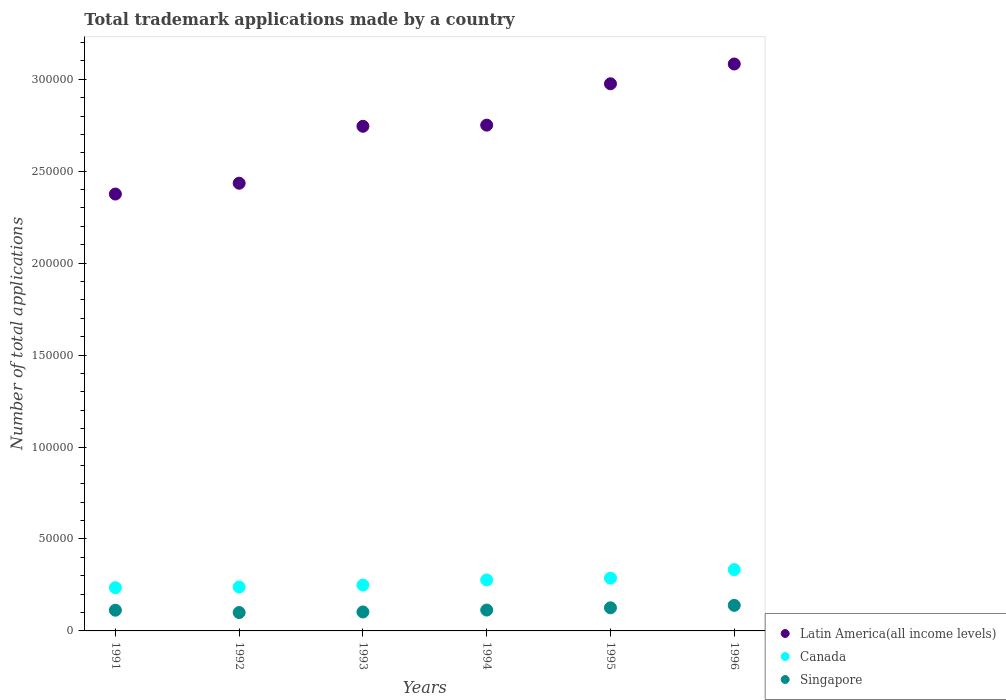What is the number of applications made by in Canada in 1994?
Make the answer very short. 2.77e+04. Across all years, what is the maximum number of applications made by in Singapore?
Offer a terse response. 1.39e+04. Across all years, what is the minimum number of applications made by in Singapore?
Make the answer very short. 9999. In which year was the number of applications made by in Singapore maximum?
Offer a terse response. 1996. What is the total number of applications made by in Singapore in the graph?
Make the answer very short. 6.94e+04. What is the difference between the number of applications made by in Singapore in 1993 and that in 1996?
Offer a terse response. -3588. What is the difference between the number of applications made by in Latin America(all income levels) in 1993 and the number of applications made by in Canada in 1996?
Give a very brief answer. 2.41e+05. What is the average number of applications made by in Canada per year?
Give a very brief answer. 2.70e+04. In the year 1993, what is the difference between the number of applications made by in Latin America(all income levels) and number of applications made by in Singapore?
Your response must be concise. 2.64e+05. What is the ratio of the number of applications made by in Singapore in 1991 to that in 1992?
Ensure brevity in your answer.  1.13. What is the difference between the highest and the second highest number of applications made by in Canada?
Ensure brevity in your answer.  4637. What is the difference between the highest and the lowest number of applications made by in Canada?
Offer a terse response. 9828. In how many years, is the number of applications made by in Canada greater than the average number of applications made by in Canada taken over all years?
Make the answer very short. 3. Is the sum of the number of applications made by in Canada in 1991 and 1993 greater than the maximum number of applications made by in Latin America(all income levels) across all years?
Your answer should be compact. No. Is the number of applications made by in Singapore strictly less than the number of applications made by in Canada over the years?
Your answer should be very brief. Yes. How many dotlines are there?
Ensure brevity in your answer.  3. Does the graph contain any zero values?
Provide a short and direct response. No. Where does the legend appear in the graph?
Your response must be concise. Bottom right. What is the title of the graph?
Your response must be concise. Total trademark applications made by a country. What is the label or title of the Y-axis?
Keep it short and to the point. Number of total applications. What is the Number of total applications of Latin America(all income levels) in 1991?
Your response must be concise. 2.38e+05. What is the Number of total applications of Canada in 1991?
Keep it short and to the point. 2.35e+04. What is the Number of total applications in Singapore in 1991?
Provide a succinct answer. 1.13e+04. What is the Number of total applications in Latin America(all income levels) in 1992?
Keep it short and to the point. 2.43e+05. What is the Number of total applications in Canada in 1992?
Keep it short and to the point. 2.39e+04. What is the Number of total applications of Singapore in 1992?
Your response must be concise. 9999. What is the Number of total applications in Latin America(all income levels) in 1993?
Offer a terse response. 2.74e+05. What is the Number of total applications in Canada in 1993?
Give a very brief answer. 2.49e+04. What is the Number of total applications in Singapore in 1993?
Offer a very short reply. 1.03e+04. What is the Number of total applications in Latin America(all income levels) in 1994?
Your response must be concise. 2.75e+05. What is the Number of total applications in Canada in 1994?
Give a very brief answer. 2.77e+04. What is the Number of total applications of Singapore in 1994?
Provide a short and direct response. 1.13e+04. What is the Number of total applications of Latin America(all income levels) in 1995?
Your response must be concise. 2.98e+05. What is the Number of total applications of Canada in 1995?
Your answer should be very brief. 2.87e+04. What is the Number of total applications in Singapore in 1995?
Provide a short and direct response. 1.26e+04. What is the Number of total applications of Latin America(all income levels) in 1996?
Make the answer very short. 3.08e+05. What is the Number of total applications of Canada in 1996?
Provide a short and direct response. 3.33e+04. What is the Number of total applications of Singapore in 1996?
Your response must be concise. 1.39e+04. Across all years, what is the maximum Number of total applications in Latin America(all income levels)?
Your answer should be very brief. 3.08e+05. Across all years, what is the maximum Number of total applications of Canada?
Keep it short and to the point. 3.33e+04. Across all years, what is the maximum Number of total applications in Singapore?
Offer a very short reply. 1.39e+04. Across all years, what is the minimum Number of total applications in Latin America(all income levels)?
Your answer should be very brief. 2.38e+05. Across all years, what is the minimum Number of total applications in Canada?
Provide a succinct answer. 2.35e+04. Across all years, what is the minimum Number of total applications of Singapore?
Offer a very short reply. 9999. What is the total Number of total applications of Latin America(all income levels) in the graph?
Give a very brief answer. 1.64e+06. What is the total Number of total applications in Canada in the graph?
Make the answer very short. 1.62e+05. What is the total Number of total applications in Singapore in the graph?
Your response must be concise. 6.94e+04. What is the difference between the Number of total applications in Latin America(all income levels) in 1991 and that in 1992?
Ensure brevity in your answer.  -5886. What is the difference between the Number of total applications of Canada in 1991 and that in 1992?
Make the answer very short. -362. What is the difference between the Number of total applications in Singapore in 1991 and that in 1992?
Offer a very short reply. 1267. What is the difference between the Number of total applications in Latin America(all income levels) in 1991 and that in 1993?
Your answer should be compact. -3.69e+04. What is the difference between the Number of total applications in Canada in 1991 and that in 1993?
Your answer should be compact. -1424. What is the difference between the Number of total applications in Singapore in 1991 and that in 1993?
Your answer should be compact. 955. What is the difference between the Number of total applications of Latin America(all income levels) in 1991 and that in 1994?
Your answer should be compact. -3.75e+04. What is the difference between the Number of total applications of Canada in 1991 and that in 1994?
Provide a succinct answer. -4217. What is the difference between the Number of total applications in Singapore in 1991 and that in 1994?
Provide a short and direct response. -83. What is the difference between the Number of total applications in Latin America(all income levels) in 1991 and that in 1995?
Ensure brevity in your answer.  -6.00e+04. What is the difference between the Number of total applications in Canada in 1991 and that in 1995?
Keep it short and to the point. -5191. What is the difference between the Number of total applications in Singapore in 1991 and that in 1995?
Your answer should be very brief. -1311. What is the difference between the Number of total applications of Latin America(all income levels) in 1991 and that in 1996?
Your answer should be very brief. -7.07e+04. What is the difference between the Number of total applications of Canada in 1991 and that in 1996?
Offer a very short reply. -9828. What is the difference between the Number of total applications of Singapore in 1991 and that in 1996?
Your response must be concise. -2633. What is the difference between the Number of total applications of Latin America(all income levels) in 1992 and that in 1993?
Your answer should be very brief. -3.10e+04. What is the difference between the Number of total applications in Canada in 1992 and that in 1993?
Make the answer very short. -1062. What is the difference between the Number of total applications of Singapore in 1992 and that in 1993?
Offer a terse response. -312. What is the difference between the Number of total applications in Latin America(all income levels) in 1992 and that in 1994?
Give a very brief answer. -3.16e+04. What is the difference between the Number of total applications in Canada in 1992 and that in 1994?
Your response must be concise. -3855. What is the difference between the Number of total applications in Singapore in 1992 and that in 1994?
Make the answer very short. -1350. What is the difference between the Number of total applications of Latin America(all income levels) in 1992 and that in 1995?
Your answer should be compact. -5.41e+04. What is the difference between the Number of total applications in Canada in 1992 and that in 1995?
Your response must be concise. -4829. What is the difference between the Number of total applications in Singapore in 1992 and that in 1995?
Offer a very short reply. -2578. What is the difference between the Number of total applications in Latin America(all income levels) in 1992 and that in 1996?
Ensure brevity in your answer.  -6.48e+04. What is the difference between the Number of total applications in Canada in 1992 and that in 1996?
Keep it short and to the point. -9466. What is the difference between the Number of total applications of Singapore in 1992 and that in 1996?
Ensure brevity in your answer.  -3900. What is the difference between the Number of total applications in Latin America(all income levels) in 1993 and that in 1994?
Offer a very short reply. -624. What is the difference between the Number of total applications in Canada in 1993 and that in 1994?
Provide a short and direct response. -2793. What is the difference between the Number of total applications in Singapore in 1993 and that in 1994?
Your answer should be compact. -1038. What is the difference between the Number of total applications of Latin America(all income levels) in 1993 and that in 1995?
Provide a succinct answer. -2.31e+04. What is the difference between the Number of total applications of Canada in 1993 and that in 1995?
Provide a short and direct response. -3767. What is the difference between the Number of total applications of Singapore in 1993 and that in 1995?
Provide a succinct answer. -2266. What is the difference between the Number of total applications in Latin America(all income levels) in 1993 and that in 1996?
Keep it short and to the point. -3.39e+04. What is the difference between the Number of total applications in Canada in 1993 and that in 1996?
Make the answer very short. -8404. What is the difference between the Number of total applications of Singapore in 1993 and that in 1996?
Your answer should be very brief. -3588. What is the difference between the Number of total applications of Latin America(all income levels) in 1994 and that in 1995?
Ensure brevity in your answer.  -2.25e+04. What is the difference between the Number of total applications of Canada in 1994 and that in 1995?
Keep it short and to the point. -974. What is the difference between the Number of total applications of Singapore in 1994 and that in 1995?
Your answer should be very brief. -1228. What is the difference between the Number of total applications in Latin America(all income levels) in 1994 and that in 1996?
Your response must be concise. -3.32e+04. What is the difference between the Number of total applications of Canada in 1994 and that in 1996?
Keep it short and to the point. -5611. What is the difference between the Number of total applications of Singapore in 1994 and that in 1996?
Give a very brief answer. -2550. What is the difference between the Number of total applications of Latin America(all income levels) in 1995 and that in 1996?
Provide a succinct answer. -1.07e+04. What is the difference between the Number of total applications in Canada in 1995 and that in 1996?
Your response must be concise. -4637. What is the difference between the Number of total applications in Singapore in 1995 and that in 1996?
Offer a terse response. -1322. What is the difference between the Number of total applications in Latin America(all income levels) in 1991 and the Number of total applications in Canada in 1992?
Your answer should be compact. 2.14e+05. What is the difference between the Number of total applications of Latin America(all income levels) in 1991 and the Number of total applications of Singapore in 1992?
Your response must be concise. 2.28e+05. What is the difference between the Number of total applications of Canada in 1991 and the Number of total applications of Singapore in 1992?
Keep it short and to the point. 1.35e+04. What is the difference between the Number of total applications in Latin America(all income levels) in 1991 and the Number of total applications in Canada in 1993?
Make the answer very short. 2.13e+05. What is the difference between the Number of total applications in Latin America(all income levels) in 1991 and the Number of total applications in Singapore in 1993?
Ensure brevity in your answer.  2.27e+05. What is the difference between the Number of total applications in Canada in 1991 and the Number of total applications in Singapore in 1993?
Your response must be concise. 1.32e+04. What is the difference between the Number of total applications in Latin America(all income levels) in 1991 and the Number of total applications in Canada in 1994?
Ensure brevity in your answer.  2.10e+05. What is the difference between the Number of total applications in Latin America(all income levels) in 1991 and the Number of total applications in Singapore in 1994?
Your answer should be compact. 2.26e+05. What is the difference between the Number of total applications in Canada in 1991 and the Number of total applications in Singapore in 1994?
Your answer should be compact. 1.22e+04. What is the difference between the Number of total applications in Latin America(all income levels) in 1991 and the Number of total applications in Canada in 1995?
Provide a succinct answer. 2.09e+05. What is the difference between the Number of total applications of Latin America(all income levels) in 1991 and the Number of total applications of Singapore in 1995?
Offer a very short reply. 2.25e+05. What is the difference between the Number of total applications in Canada in 1991 and the Number of total applications in Singapore in 1995?
Offer a terse response. 1.09e+04. What is the difference between the Number of total applications in Latin America(all income levels) in 1991 and the Number of total applications in Canada in 1996?
Make the answer very short. 2.04e+05. What is the difference between the Number of total applications of Latin America(all income levels) in 1991 and the Number of total applications of Singapore in 1996?
Make the answer very short. 2.24e+05. What is the difference between the Number of total applications in Canada in 1991 and the Number of total applications in Singapore in 1996?
Provide a short and direct response. 9614. What is the difference between the Number of total applications of Latin America(all income levels) in 1992 and the Number of total applications of Canada in 1993?
Your answer should be compact. 2.19e+05. What is the difference between the Number of total applications in Latin America(all income levels) in 1992 and the Number of total applications in Singapore in 1993?
Offer a terse response. 2.33e+05. What is the difference between the Number of total applications of Canada in 1992 and the Number of total applications of Singapore in 1993?
Your response must be concise. 1.36e+04. What is the difference between the Number of total applications of Latin America(all income levels) in 1992 and the Number of total applications of Canada in 1994?
Make the answer very short. 2.16e+05. What is the difference between the Number of total applications of Latin America(all income levels) in 1992 and the Number of total applications of Singapore in 1994?
Offer a very short reply. 2.32e+05. What is the difference between the Number of total applications in Canada in 1992 and the Number of total applications in Singapore in 1994?
Give a very brief answer. 1.25e+04. What is the difference between the Number of total applications of Latin America(all income levels) in 1992 and the Number of total applications of Canada in 1995?
Provide a succinct answer. 2.15e+05. What is the difference between the Number of total applications in Latin America(all income levels) in 1992 and the Number of total applications in Singapore in 1995?
Your answer should be very brief. 2.31e+05. What is the difference between the Number of total applications of Canada in 1992 and the Number of total applications of Singapore in 1995?
Provide a succinct answer. 1.13e+04. What is the difference between the Number of total applications of Latin America(all income levels) in 1992 and the Number of total applications of Canada in 1996?
Keep it short and to the point. 2.10e+05. What is the difference between the Number of total applications in Latin America(all income levels) in 1992 and the Number of total applications in Singapore in 1996?
Ensure brevity in your answer.  2.30e+05. What is the difference between the Number of total applications in Canada in 1992 and the Number of total applications in Singapore in 1996?
Make the answer very short. 9976. What is the difference between the Number of total applications in Latin America(all income levels) in 1993 and the Number of total applications in Canada in 1994?
Offer a terse response. 2.47e+05. What is the difference between the Number of total applications of Latin America(all income levels) in 1993 and the Number of total applications of Singapore in 1994?
Keep it short and to the point. 2.63e+05. What is the difference between the Number of total applications of Canada in 1993 and the Number of total applications of Singapore in 1994?
Your answer should be compact. 1.36e+04. What is the difference between the Number of total applications in Latin America(all income levels) in 1993 and the Number of total applications in Canada in 1995?
Ensure brevity in your answer.  2.46e+05. What is the difference between the Number of total applications of Latin America(all income levels) in 1993 and the Number of total applications of Singapore in 1995?
Make the answer very short. 2.62e+05. What is the difference between the Number of total applications of Canada in 1993 and the Number of total applications of Singapore in 1995?
Give a very brief answer. 1.24e+04. What is the difference between the Number of total applications in Latin America(all income levels) in 1993 and the Number of total applications in Canada in 1996?
Keep it short and to the point. 2.41e+05. What is the difference between the Number of total applications in Latin America(all income levels) in 1993 and the Number of total applications in Singapore in 1996?
Offer a very short reply. 2.61e+05. What is the difference between the Number of total applications in Canada in 1993 and the Number of total applications in Singapore in 1996?
Make the answer very short. 1.10e+04. What is the difference between the Number of total applications in Latin America(all income levels) in 1994 and the Number of total applications in Canada in 1995?
Offer a terse response. 2.46e+05. What is the difference between the Number of total applications of Latin America(all income levels) in 1994 and the Number of total applications of Singapore in 1995?
Provide a short and direct response. 2.62e+05. What is the difference between the Number of total applications of Canada in 1994 and the Number of total applications of Singapore in 1995?
Offer a very short reply. 1.52e+04. What is the difference between the Number of total applications of Latin America(all income levels) in 1994 and the Number of total applications of Canada in 1996?
Your answer should be very brief. 2.42e+05. What is the difference between the Number of total applications in Latin America(all income levels) in 1994 and the Number of total applications in Singapore in 1996?
Ensure brevity in your answer.  2.61e+05. What is the difference between the Number of total applications in Canada in 1994 and the Number of total applications in Singapore in 1996?
Ensure brevity in your answer.  1.38e+04. What is the difference between the Number of total applications in Latin America(all income levels) in 1995 and the Number of total applications in Canada in 1996?
Your answer should be compact. 2.64e+05. What is the difference between the Number of total applications in Latin America(all income levels) in 1995 and the Number of total applications in Singapore in 1996?
Provide a short and direct response. 2.84e+05. What is the difference between the Number of total applications in Canada in 1995 and the Number of total applications in Singapore in 1996?
Offer a terse response. 1.48e+04. What is the average Number of total applications in Latin America(all income levels) per year?
Provide a short and direct response. 2.73e+05. What is the average Number of total applications in Canada per year?
Make the answer very short. 2.70e+04. What is the average Number of total applications in Singapore per year?
Your response must be concise. 1.16e+04. In the year 1991, what is the difference between the Number of total applications of Latin America(all income levels) and Number of total applications of Canada?
Give a very brief answer. 2.14e+05. In the year 1991, what is the difference between the Number of total applications of Latin America(all income levels) and Number of total applications of Singapore?
Offer a very short reply. 2.26e+05. In the year 1991, what is the difference between the Number of total applications of Canada and Number of total applications of Singapore?
Provide a succinct answer. 1.22e+04. In the year 1992, what is the difference between the Number of total applications in Latin America(all income levels) and Number of total applications in Canada?
Provide a succinct answer. 2.20e+05. In the year 1992, what is the difference between the Number of total applications of Latin America(all income levels) and Number of total applications of Singapore?
Your answer should be compact. 2.33e+05. In the year 1992, what is the difference between the Number of total applications of Canada and Number of total applications of Singapore?
Keep it short and to the point. 1.39e+04. In the year 1993, what is the difference between the Number of total applications of Latin America(all income levels) and Number of total applications of Canada?
Provide a succinct answer. 2.49e+05. In the year 1993, what is the difference between the Number of total applications of Latin America(all income levels) and Number of total applications of Singapore?
Your response must be concise. 2.64e+05. In the year 1993, what is the difference between the Number of total applications in Canada and Number of total applications in Singapore?
Provide a succinct answer. 1.46e+04. In the year 1994, what is the difference between the Number of total applications of Latin America(all income levels) and Number of total applications of Canada?
Provide a short and direct response. 2.47e+05. In the year 1994, what is the difference between the Number of total applications in Latin America(all income levels) and Number of total applications in Singapore?
Provide a succinct answer. 2.64e+05. In the year 1994, what is the difference between the Number of total applications of Canada and Number of total applications of Singapore?
Provide a short and direct response. 1.64e+04. In the year 1995, what is the difference between the Number of total applications in Latin America(all income levels) and Number of total applications in Canada?
Offer a very short reply. 2.69e+05. In the year 1995, what is the difference between the Number of total applications in Latin America(all income levels) and Number of total applications in Singapore?
Offer a terse response. 2.85e+05. In the year 1995, what is the difference between the Number of total applications in Canada and Number of total applications in Singapore?
Your response must be concise. 1.61e+04. In the year 1996, what is the difference between the Number of total applications in Latin America(all income levels) and Number of total applications in Canada?
Your response must be concise. 2.75e+05. In the year 1996, what is the difference between the Number of total applications of Latin America(all income levels) and Number of total applications of Singapore?
Make the answer very short. 2.94e+05. In the year 1996, what is the difference between the Number of total applications in Canada and Number of total applications in Singapore?
Ensure brevity in your answer.  1.94e+04. What is the ratio of the Number of total applications of Latin America(all income levels) in 1991 to that in 1992?
Ensure brevity in your answer.  0.98. What is the ratio of the Number of total applications in Canada in 1991 to that in 1992?
Keep it short and to the point. 0.98. What is the ratio of the Number of total applications of Singapore in 1991 to that in 1992?
Your answer should be compact. 1.13. What is the ratio of the Number of total applications of Latin America(all income levels) in 1991 to that in 1993?
Your answer should be compact. 0.87. What is the ratio of the Number of total applications in Canada in 1991 to that in 1993?
Offer a terse response. 0.94. What is the ratio of the Number of total applications of Singapore in 1991 to that in 1993?
Offer a very short reply. 1.09. What is the ratio of the Number of total applications of Latin America(all income levels) in 1991 to that in 1994?
Give a very brief answer. 0.86. What is the ratio of the Number of total applications in Canada in 1991 to that in 1994?
Provide a short and direct response. 0.85. What is the ratio of the Number of total applications of Singapore in 1991 to that in 1994?
Your answer should be compact. 0.99. What is the ratio of the Number of total applications in Latin America(all income levels) in 1991 to that in 1995?
Your answer should be very brief. 0.8. What is the ratio of the Number of total applications of Canada in 1991 to that in 1995?
Offer a terse response. 0.82. What is the ratio of the Number of total applications in Singapore in 1991 to that in 1995?
Give a very brief answer. 0.9. What is the ratio of the Number of total applications in Latin America(all income levels) in 1991 to that in 1996?
Your answer should be compact. 0.77. What is the ratio of the Number of total applications of Canada in 1991 to that in 1996?
Your answer should be compact. 0.71. What is the ratio of the Number of total applications of Singapore in 1991 to that in 1996?
Keep it short and to the point. 0.81. What is the ratio of the Number of total applications of Latin America(all income levels) in 1992 to that in 1993?
Ensure brevity in your answer.  0.89. What is the ratio of the Number of total applications of Canada in 1992 to that in 1993?
Make the answer very short. 0.96. What is the ratio of the Number of total applications in Singapore in 1992 to that in 1993?
Offer a very short reply. 0.97. What is the ratio of the Number of total applications of Latin America(all income levels) in 1992 to that in 1994?
Keep it short and to the point. 0.89. What is the ratio of the Number of total applications in Canada in 1992 to that in 1994?
Your response must be concise. 0.86. What is the ratio of the Number of total applications of Singapore in 1992 to that in 1994?
Your answer should be very brief. 0.88. What is the ratio of the Number of total applications of Latin America(all income levels) in 1992 to that in 1995?
Give a very brief answer. 0.82. What is the ratio of the Number of total applications in Canada in 1992 to that in 1995?
Make the answer very short. 0.83. What is the ratio of the Number of total applications of Singapore in 1992 to that in 1995?
Your response must be concise. 0.8. What is the ratio of the Number of total applications in Latin America(all income levels) in 1992 to that in 1996?
Provide a short and direct response. 0.79. What is the ratio of the Number of total applications of Canada in 1992 to that in 1996?
Provide a succinct answer. 0.72. What is the ratio of the Number of total applications of Singapore in 1992 to that in 1996?
Keep it short and to the point. 0.72. What is the ratio of the Number of total applications in Latin America(all income levels) in 1993 to that in 1994?
Your answer should be very brief. 1. What is the ratio of the Number of total applications of Canada in 1993 to that in 1994?
Give a very brief answer. 0.9. What is the ratio of the Number of total applications of Singapore in 1993 to that in 1994?
Make the answer very short. 0.91. What is the ratio of the Number of total applications of Latin America(all income levels) in 1993 to that in 1995?
Provide a succinct answer. 0.92. What is the ratio of the Number of total applications of Canada in 1993 to that in 1995?
Keep it short and to the point. 0.87. What is the ratio of the Number of total applications in Singapore in 1993 to that in 1995?
Make the answer very short. 0.82. What is the ratio of the Number of total applications of Latin America(all income levels) in 1993 to that in 1996?
Your answer should be very brief. 0.89. What is the ratio of the Number of total applications of Canada in 1993 to that in 1996?
Make the answer very short. 0.75. What is the ratio of the Number of total applications in Singapore in 1993 to that in 1996?
Offer a very short reply. 0.74. What is the ratio of the Number of total applications of Latin America(all income levels) in 1994 to that in 1995?
Provide a short and direct response. 0.92. What is the ratio of the Number of total applications of Canada in 1994 to that in 1995?
Provide a succinct answer. 0.97. What is the ratio of the Number of total applications of Singapore in 1994 to that in 1995?
Ensure brevity in your answer.  0.9. What is the ratio of the Number of total applications of Latin America(all income levels) in 1994 to that in 1996?
Offer a very short reply. 0.89. What is the ratio of the Number of total applications of Canada in 1994 to that in 1996?
Provide a short and direct response. 0.83. What is the ratio of the Number of total applications of Singapore in 1994 to that in 1996?
Make the answer very short. 0.82. What is the ratio of the Number of total applications of Latin America(all income levels) in 1995 to that in 1996?
Offer a very short reply. 0.97. What is the ratio of the Number of total applications in Canada in 1995 to that in 1996?
Offer a terse response. 0.86. What is the ratio of the Number of total applications in Singapore in 1995 to that in 1996?
Your answer should be very brief. 0.9. What is the difference between the highest and the second highest Number of total applications of Latin America(all income levels)?
Give a very brief answer. 1.07e+04. What is the difference between the highest and the second highest Number of total applications in Canada?
Make the answer very short. 4637. What is the difference between the highest and the second highest Number of total applications in Singapore?
Offer a very short reply. 1322. What is the difference between the highest and the lowest Number of total applications of Latin America(all income levels)?
Your answer should be compact. 7.07e+04. What is the difference between the highest and the lowest Number of total applications of Canada?
Offer a terse response. 9828. What is the difference between the highest and the lowest Number of total applications of Singapore?
Your response must be concise. 3900. 